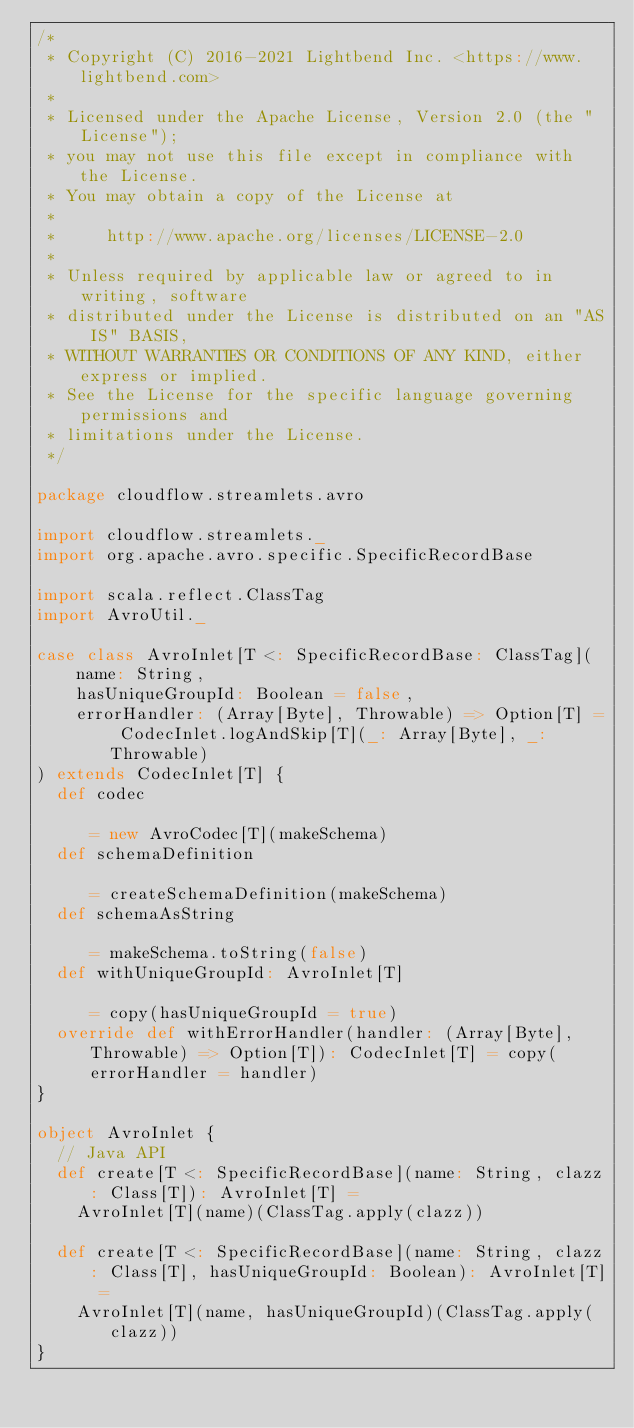<code> <loc_0><loc_0><loc_500><loc_500><_Scala_>/*
 * Copyright (C) 2016-2021 Lightbend Inc. <https://www.lightbend.com>
 *
 * Licensed under the Apache License, Version 2.0 (the "License");
 * you may not use this file except in compliance with the License.
 * You may obtain a copy of the License at
 *
 *     http://www.apache.org/licenses/LICENSE-2.0
 *
 * Unless required by applicable law or agreed to in writing, software
 * distributed under the License is distributed on an "AS IS" BASIS,
 * WITHOUT WARRANTIES OR CONDITIONS OF ANY KIND, either express or implied.
 * See the License for the specific language governing permissions and
 * limitations under the License.
 */

package cloudflow.streamlets.avro

import cloudflow.streamlets._
import org.apache.avro.specific.SpecificRecordBase

import scala.reflect.ClassTag
import AvroUtil._

case class AvroInlet[T <: SpecificRecordBase: ClassTag](
    name: String,
    hasUniqueGroupId: Boolean = false,
    errorHandler: (Array[Byte], Throwable) => Option[T] = CodecInlet.logAndSkip[T](_: Array[Byte], _: Throwable)
) extends CodecInlet[T] {
  def codec                                                                                    = new AvroCodec[T](makeSchema)
  def schemaDefinition                                                                         = createSchemaDefinition(makeSchema)
  def schemaAsString                                                                           = makeSchema.toString(false)
  def withUniqueGroupId: AvroInlet[T]                                                          = copy(hasUniqueGroupId = true)
  override def withErrorHandler(handler: (Array[Byte], Throwable) => Option[T]): CodecInlet[T] = copy(errorHandler = handler)
}

object AvroInlet {
  // Java API
  def create[T <: SpecificRecordBase](name: String, clazz: Class[T]): AvroInlet[T] =
    AvroInlet[T](name)(ClassTag.apply(clazz))

  def create[T <: SpecificRecordBase](name: String, clazz: Class[T], hasUniqueGroupId: Boolean): AvroInlet[T] =
    AvroInlet[T](name, hasUniqueGroupId)(ClassTag.apply(clazz))
}
</code> 